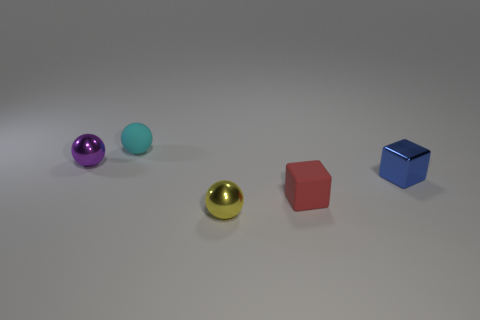Subtract all metallic spheres. How many spheres are left? 1 Subtract 1 spheres. How many spheres are left? 2 Add 1 cyan rubber cylinders. How many objects exist? 6 Subtract all balls. How many objects are left? 2 Subtract all big red matte cylinders. Subtract all tiny purple metallic objects. How many objects are left? 4 Add 5 tiny purple spheres. How many tiny purple spheres are left? 6 Add 5 tiny blue cubes. How many tiny blue cubes exist? 6 Subtract 0 red cylinders. How many objects are left? 5 